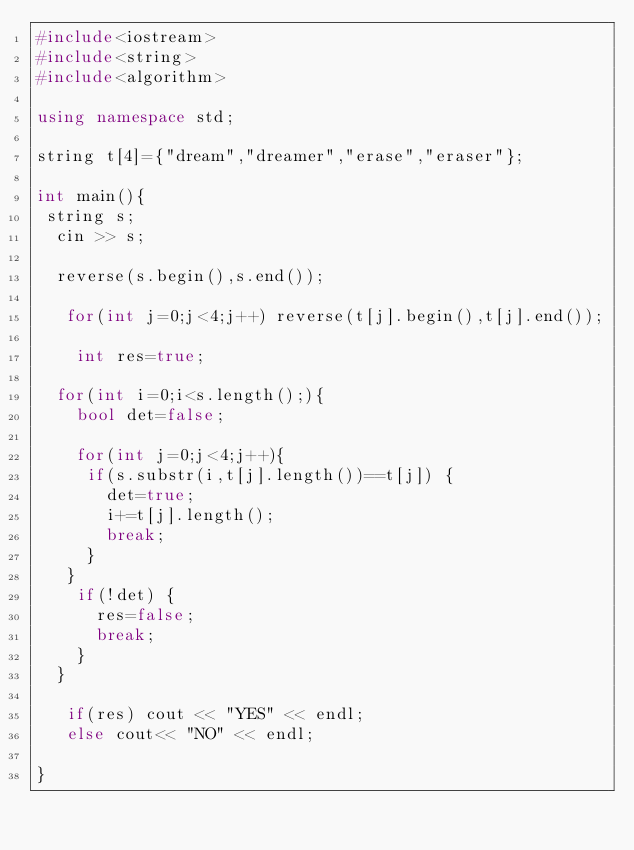Convert code to text. <code><loc_0><loc_0><loc_500><loc_500><_C++_>#include<iostream>
#include<string>
#include<algorithm>

using namespace std;

string t[4]={"dream","dreamer","erase","eraser"};

int main(){
 string s;
  cin >> s;
  
  reverse(s.begin(),s.end());
  
   for(int j=0;j<4;j++) reverse(t[j].begin(),t[j].end());
  
    int res=true;
  
  for(int i=0;i<s.length();){
    bool det=false;
    
    for(int j=0;j<4;j++){
     if(s.substr(i,t[j].length())==t[j]) {
       det=true; 
       i+=t[j].length();
       break;
     }
   }
    if(!det) {
      res=false; 
      break;
    }
  }

   if(res) cout << "YES" << endl;
   else cout<< "NO" << endl;

}</code> 